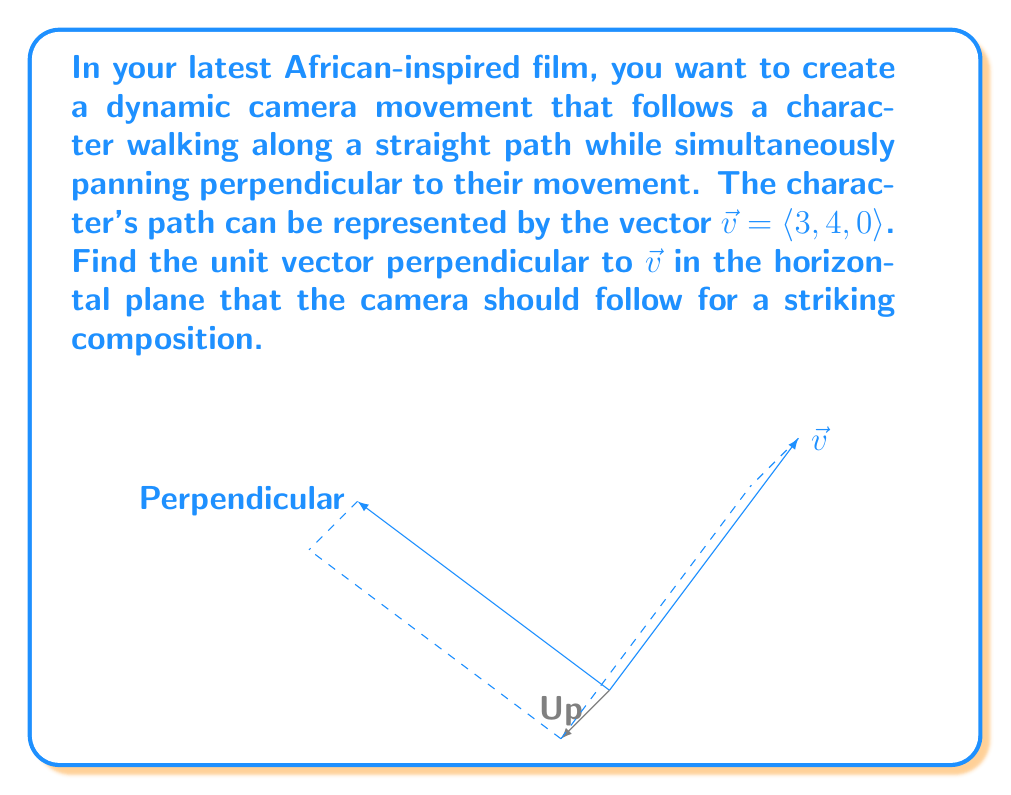Can you answer this question? To find the perpendicular vector in the horizontal plane, we can follow these steps:

1) The vector $\vec{v} = \langle 3, 4, 0 \rangle$ represents the character's path.

2) To find a perpendicular vector in the horizontal plane, we can use the cross product of $\vec{v}$ with the vertical unit vector $\hat{k} = \langle 0, 0, 1 \rangle$:

   $\vec{u} = \vec{v} \times \hat{k} = \begin{vmatrix} 
   \hat{i} & \hat{j} & \hat{k} \\
   3 & 4 & 0 \\
   0 & 0 & 1
   \end{vmatrix} = \langle 4, -3, 0 \rangle$

3) This vector $\vec{u}$ is perpendicular to both $\vec{v}$ and the vertical direction.

4) To get the unit vector, we need to normalize $\vec{u}$:

   $\hat{u} = \frac{\vec{u}}{|\vec{u}|} = \frac{\langle 4, -3, 0 \rangle}{\sqrt{4^2 + (-3)^2 + 0^2}} = \frac{\langle 4, -3, 0 \rangle}{5}$

5) Simplifying:

   $\hat{u} = \langle \frac{4}{5}, -\frac{3}{5}, 0 \rangle$

This unit vector represents the direction the camera should pan for a perpendicular movement to the character's path, creating a dynamic and visually striking composition.
Answer: $\langle \frac{4}{5}, -\frac{3}{5}, 0 \rangle$ 